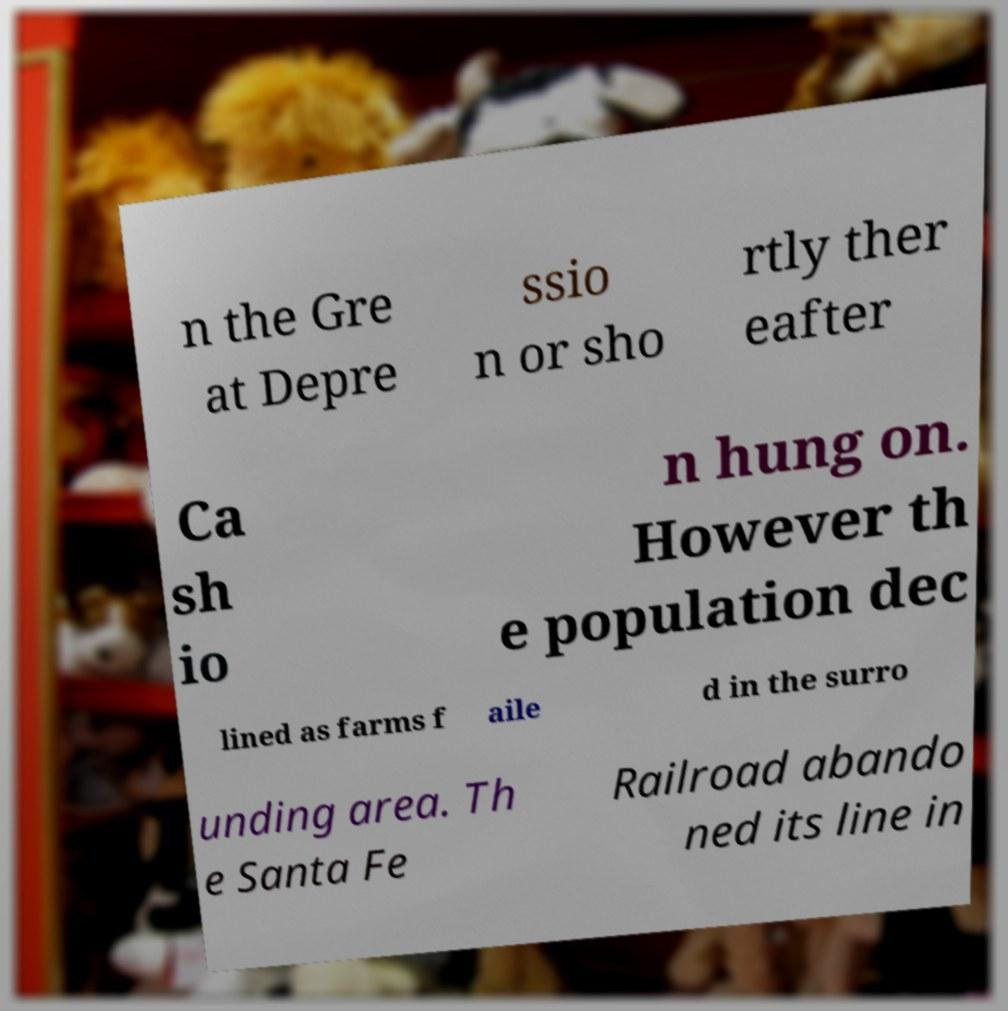Could you extract and type out the text from this image? n the Gre at Depre ssio n or sho rtly ther eafter Ca sh io n hung on. However th e population dec lined as farms f aile d in the surro unding area. Th e Santa Fe Railroad abando ned its line in 